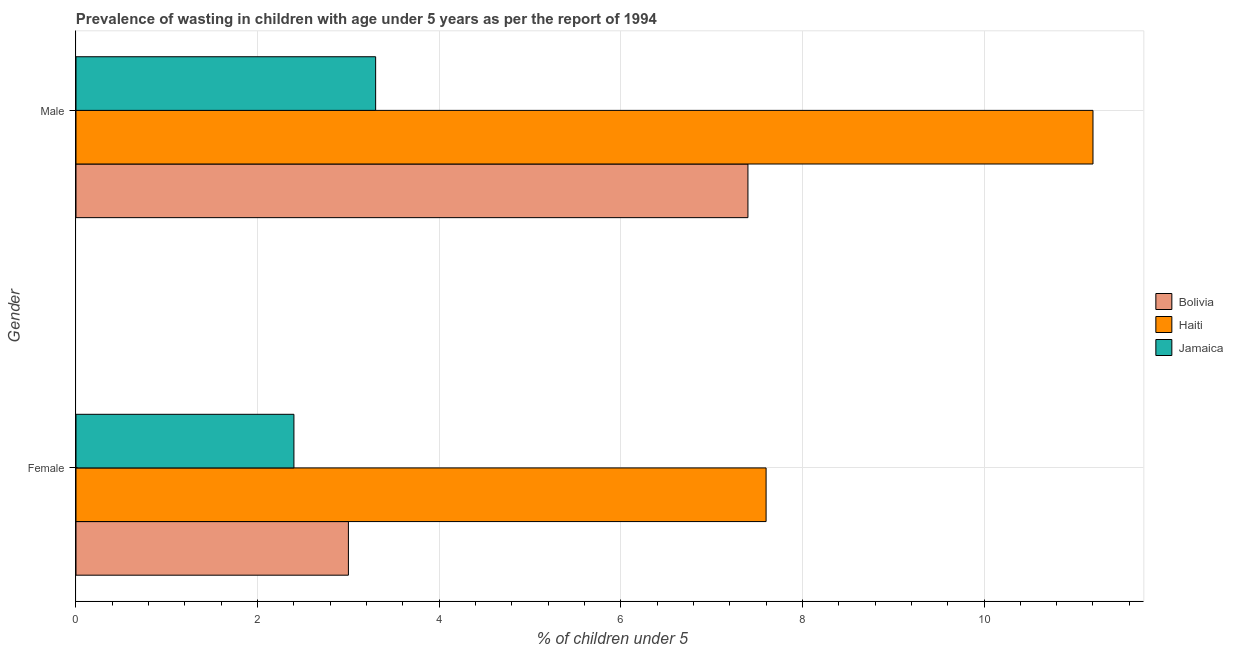Are the number of bars per tick equal to the number of legend labels?
Offer a terse response. Yes. How many bars are there on the 1st tick from the bottom?
Provide a succinct answer. 3. What is the percentage of undernourished female children in Bolivia?
Your response must be concise. 3. Across all countries, what is the maximum percentage of undernourished female children?
Give a very brief answer. 7.6. Across all countries, what is the minimum percentage of undernourished female children?
Your answer should be compact. 2.4. In which country was the percentage of undernourished female children maximum?
Give a very brief answer. Haiti. In which country was the percentage of undernourished female children minimum?
Make the answer very short. Jamaica. What is the total percentage of undernourished female children in the graph?
Keep it short and to the point. 13. What is the difference between the percentage of undernourished female children in Jamaica and that in Haiti?
Offer a very short reply. -5.2. What is the difference between the percentage of undernourished female children in Bolivia and the percentage of undernourished male children in Jamaica?
Make the answer very short. -0.3. What is the average percentage of undernourished female children per country?
Offer a terse response. 4.33. What is the difference between the percentage of undernourished male children and percentage of undernourished female children in Haiti?
Your answer should be very brief. 3.6. In how many countries, is the percentage of undernourished male children greater than 0.8 %?
Keep it short and to the point. 3. What is the ratio of the percentage of undernourished male children in Haiti to that in Bolivia?
Your answer should be compact. 1.51. Is the percentage of undernourished male children in Jamaica less than that in Bolivia?
Ensure brevity in your answer.  Yes. What does the 1st bar from the top in Male represents?
Give a very brief answer. Jamaica. What does the 2nd bar from the bottom in Male represents?
Your response must be concise. Haiti. Are all the bars in the graph horizontal?
Your response must be concise. Yes. How many countries are there in the graph?
Ensure brevity in your answer.  3. Are the values on the major ticks of X-axis written in scientific E-notation?
Provide a short and direct response. No. Does the graph contain any zero values?
Your answer should be compact. No. Does the graph contain grids?
Offer a terse response. Yes. How many legend labels are there?
Provide a short and direct response. 3. What is the title of the graph?
Give a very brief answer. Prevalence of wasting in children with age under 5 years as per the report of 1994. Does "Andorra" appear as one of the legend labels in the graph?
Offer a terse response. No. What is the label or title of the X-axis?
Your answer should be compact.  % of children under 5. What is the  % of children under 5 in Bolivia in Female?
Make the answer very short. 3. What is the  % of children under 5 in Haiti in Female?
Offer a terse response. 7.6. What is the  % of children under 5 of Jamaica in Female?
Keep it short and to the point. 2.4. What is the  % of children under 5 of Bolivia in Male?
Provide a succinct answer. 7.4. What is the  % of children under 5 of Haiti in Male?
Offer a very short reply. 11.2. What is the  % of children under 5 of Jamaica in Male?
Your answer should be compact. 3.3. Across all Gender, what is the maximum  % of children under 5 of Bolivia?
Offer a very short reply. 7.4. Across all Gender, what is the maximum  % of children under 5 of Haiti?
Keep it short and to the point. 11.2. Across all Gender, what is the maximum  % of children under 5 in Jamaica?
Your response must be concise. 3.3. Across all Gender, what is the minimum  % of children under 5 in Haiti?
Your answer should be compact. 7.6. Across all Gender, what is the minimum  % of children under 5 of Jamaica?
Offer a terse response. 2.4. What is the total  % of children under 5 of Haiti in the graph?
Provide a short and direct response. 18.8. What is the difference between the  % of children under 5 of Bolivia in Female and that in Male?
Your answer should be very brief. -4.4. What is the difference between the  % of children under 5 of Haiti in Female and that in Male?
Your answer should be very brief. -3.6. What is the difference between the  % of children under 5 in Haiti in Female and the  % of children under 5 in Jamaica in Male?
Provide a succinct answer. 4.3. What is the average  % of children under 5 in Bolivia per Gender?
Keep it short and to the point. 5.2. What is the average  % of children under 5 in Haiti per Gender?
Make the answer very short. 9.4. What is the average  % of children under 5 in Jamaica per Gender?
Make the answer very short. 2.85. What is the difference between the  % of children under 5 of Bolivia and  % of children under 5 of Haiti in Female?
Offer a terse response. -4.6. What is the difference between the  % of children under 5 of Haiti and  % of children under 5 of Jamaica in Female?
Offer a terse response. 5.2. What is the difference between the  % of children under 5 in Bolivia and  % of children under 5 in Jamaica in Male?
Keep it short and to the point. 4.1. What is the ratio of the  % of children under 5 in Bolivia in Female to that in Male?
Make the answer very short. 0.41. What is the ratio of the  % of children under 5 of Haiti in Female to that in Male?
Offer a terse response. 0.68. What is the ratio of the  % of children under 5 of Jamaica in Female to that in Male?
Your answer should be compact. 0.73. What is the difference between the highest and the second highest  % of children under 5 of Haiti?
Keep it short and to the point. 3.6. What is the difference between the highest and the lowest  % of children under 5 in Jamaica?
Ensure brevity in your answer.  0.9. 